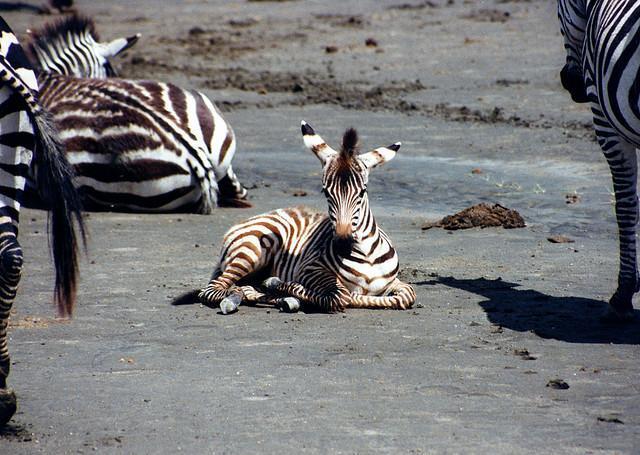How many tails are there?
Give a very brief answer. 3. How many zebras are there?
Give a very brief answer. 4. How many people are standing?
Give a very brief answer. 0. 